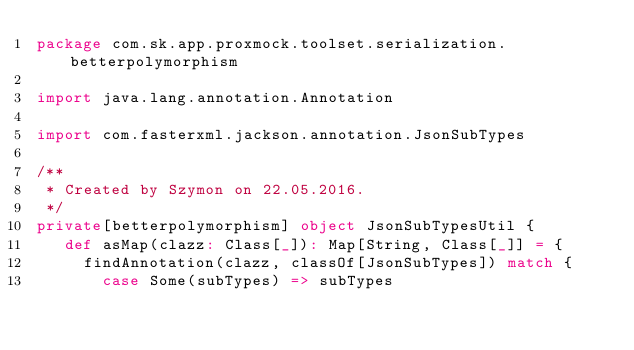<code> <loc_0><loc_0><loc_500><loc_500><_Scala_>package com.sk.app.proxmock.toolset.serialization.betterpolymorphism

import java.lang.annotation.Annotation

import com.fasterxml.jackson.annotation.JsonSubTypes

/**
 * Created by Szymon on 22.05.2016.
 */
private[betterpolymorphism] object JsonSubTypesUtil {
   def asMap(clazz: Class[_]): Map[String, Class[_]] = {
     findAnnotation(clazz, classOf[JsonSubTypes]) match {
       case Some(subTypes) => subTypes</code> 